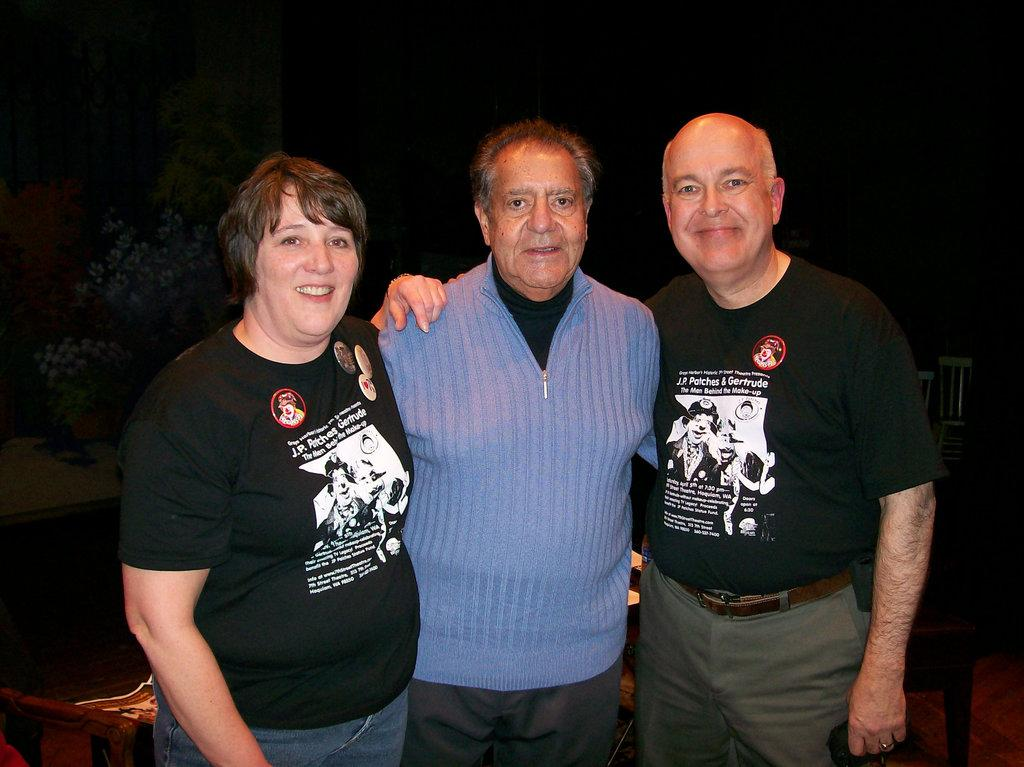How many people are in the image? There are two men and a woman in the image, making a total of three individuals. What are the people in the image doing? The individuals are standing and smiling. What can be seen in the image besides the people? There are chairs in the image. What is the color of the background in the image? The background of the image is dark. What type of quill is the laborer using in the image? There is no laborer or quill present in the image. Can you tell me how many volleyballs are visible in the image? There are no volleyballs visible in the image. 